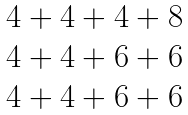Convert formula to latex. <formula><loc_0><loc_0><loc_500><loc_500>\begin{matrix} 4 + 4 + 4 + 8 \\ 4 + 4 + 6 + 6 \\ 4 + 4 + 6 + 6 \end{matrix}</formula> 